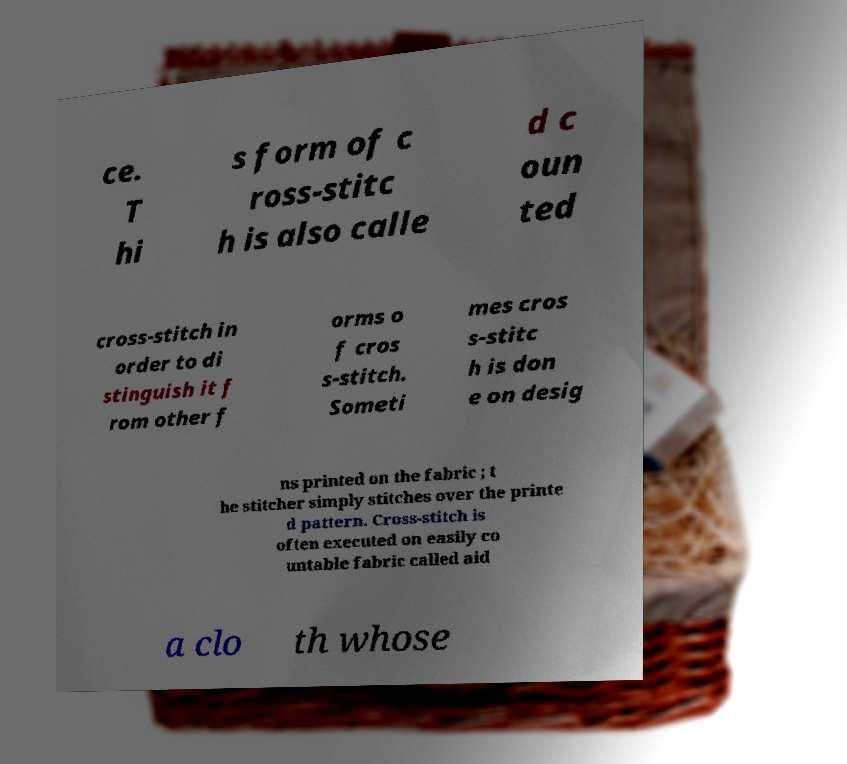Can you accurately transcribe the text from the provided image for me? ce. T hi s form of c ross-stitc h is also calle d c oun ted cross-stitch in order to di stinguish it f rom other f orms o f cros s-stitch. Someti mes cros s-stitc h is don e on desig ns printed on the fabric ; t he stitcher simply stitches over the printe d pattern. Cross-stitch is often executed on easily co untable fabric called aid a clo th whose 